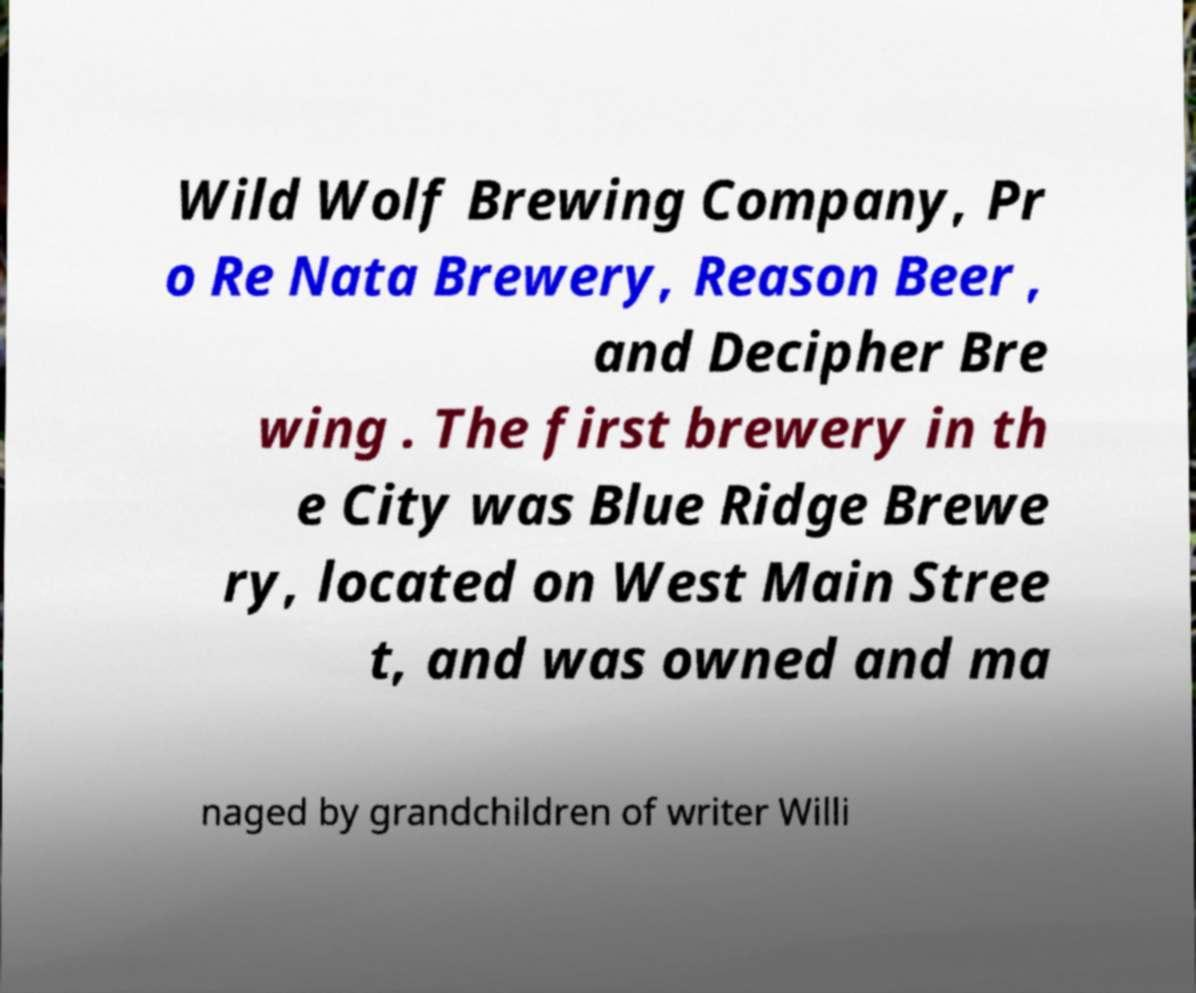Could you assist in decoding the text presented in this image and type it out clearly? Wild Wolf Brewing Company, Pr o Re Nata Brewery, Reason Beer , and Decipher Bre wing . The first brewery in th e City was Blue Ridge Brewe ry, located on West Main Stree t, and was owned and ma naged by grandchildren of writer Willi 